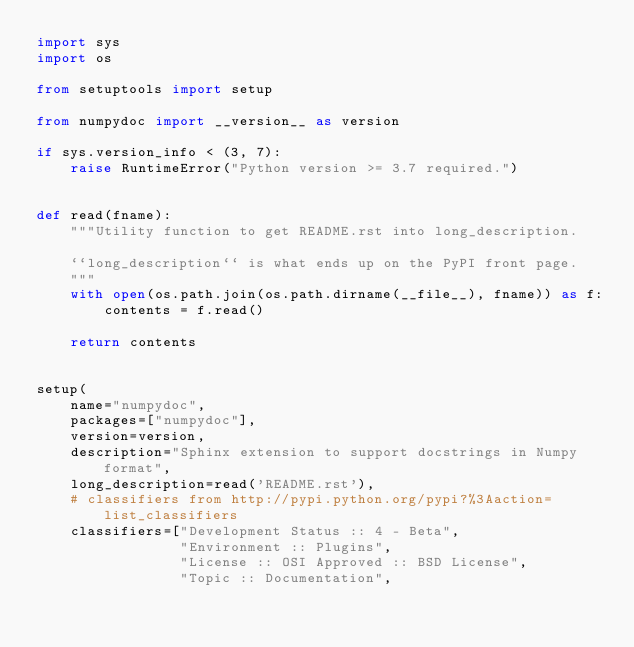<code> <loc_0><loc_0><loc_500><loc_500><_Python_>import sys
import os

from setuptools import setup

from numpydoc import __version__ as version

if sys.version_info < (3, 7):
    raise RuntimeError("Python version >= 3.7 required.")


def read(fname):
    """Utility function to get README.rst into long_description.

    ``long_description`` is what ends up on the PyPI front page.
    """
    with open(os.path.join(os.path.dirname(__file__), fname)) as f:
        contents = f.read()

    return contents


setup(
    name="numpydoc",
    packages=["numpydoc"],
    version=version,
    description="Sphinx extension to support docstrings in Numpy format",
    long_description=read('README.rst'),
    # classifiers from http://pypi.python.org/pypi?%3Aaction=list_classifiers
    classifiers=["Development Status :: 4 - Beta",
                 "Environment :: Plugins",
                 "License :: OSI Approved :: BSD License",
                 "Topic :: Documentation",</code> 